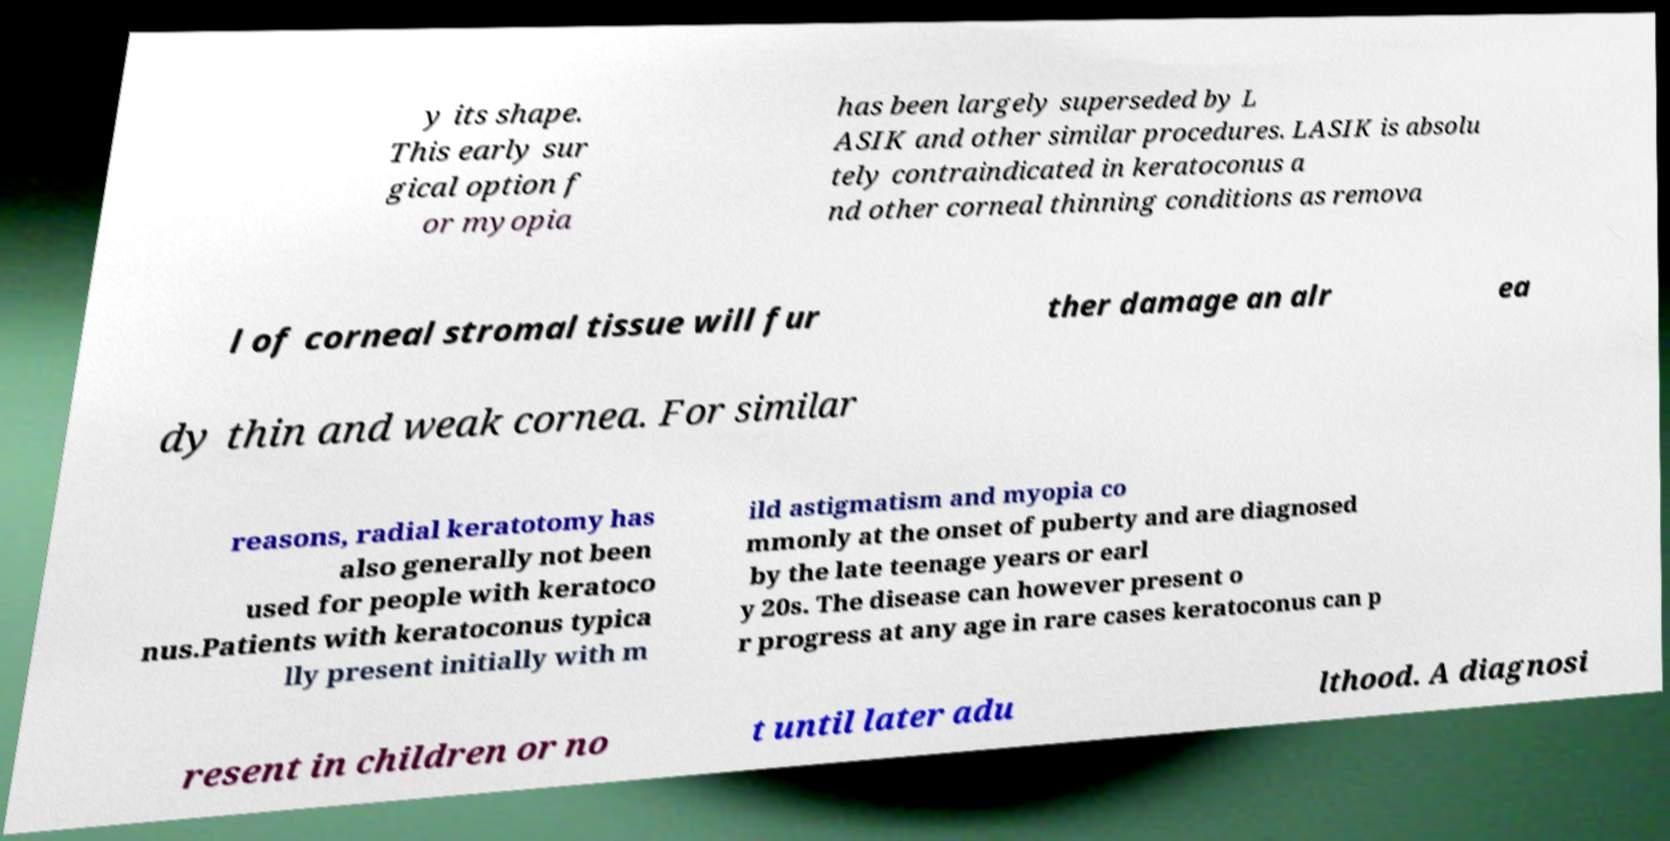Could you extract and type out the text from this image? y its shape. This early sur gical option f or myopia has been largely superseded by L ASIK and other similar procedures. LASIK is absolu tely contraindicated in keratoconus a nd other corneal thinning conditions as remova l of corneal stromal tissue will fur ther damage an alr ea dy thin and weak cornea. For similar reasons, radial keratotomy has also generally not been used for people with keratoco nus.Patients with keratoconus typica lly present initially with m ild astigmatism and myopia co mmonly at the onset of puberty and are diagnosed by the late teenage years or earl y 20s. The disease can however present o r progress at any age in rare cases keratoconus can p resent in children or no t until later adu lthood. A diagnosi 